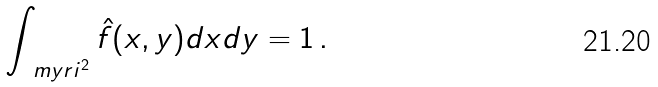<formula> <loc_0><loc_0><loc_500><loc_500>\int _ { \ m y r i ^ { 2 } } \hat { f } ( x , y ) d x d y = 1 \, .</formula> 